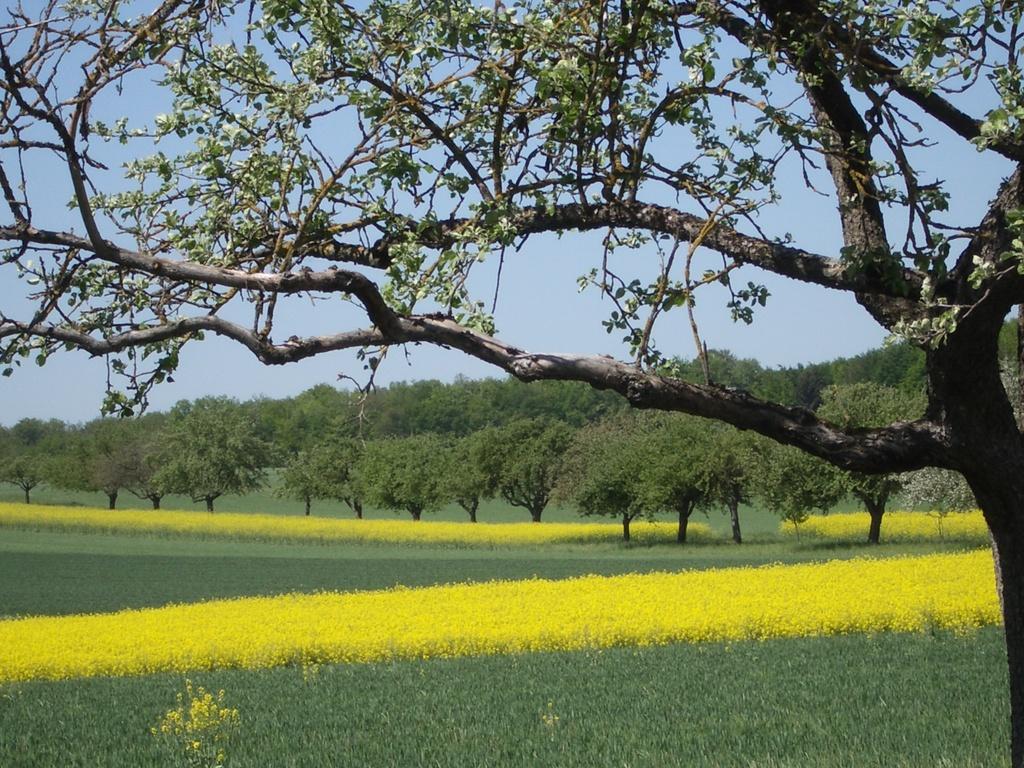Can you describe this image briefly? This is an outside view. On the right side there is a tree. At the bottom there are many plants along with the flowers which are in yellow color. In the background there are many trees. At the top of the image I can see the sky. 